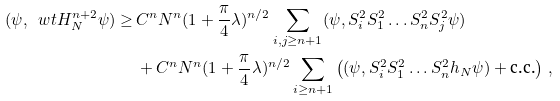<formula> <loc_0><loc_0><loc_500><loc_500>( \psi , \ w t H _ { N } ^ { n + 2 } \psi ) \geq \, & C ^ { n } N ^ { n } ( 1 + \frac { \pi } { 4 } \lambda ) ^ { n / 2 } \sum _ { i , j \geq n + 1 } ( \psi , S _ { i } ^ { 2 } S _ { 1 } ^ { 2 } \dots S _ { n } ^ { 2 } S _ { j } ^ { 2 } \psi ) \\ & + C ^ { n } N ^ { n } ( 1 + \frac { \pi } { 4 } \lambda ) ^ { n / 2 } \sum _ { i \geq n + 1 } \left ( ( \psi , S _ { i } ^ { 2 } S _ { 1 } ^ { 2 } \dots S _ { n } ^ { 2 } h _ { N } \psi ) + \text {c.c.} \right ) \, ,</formula> 